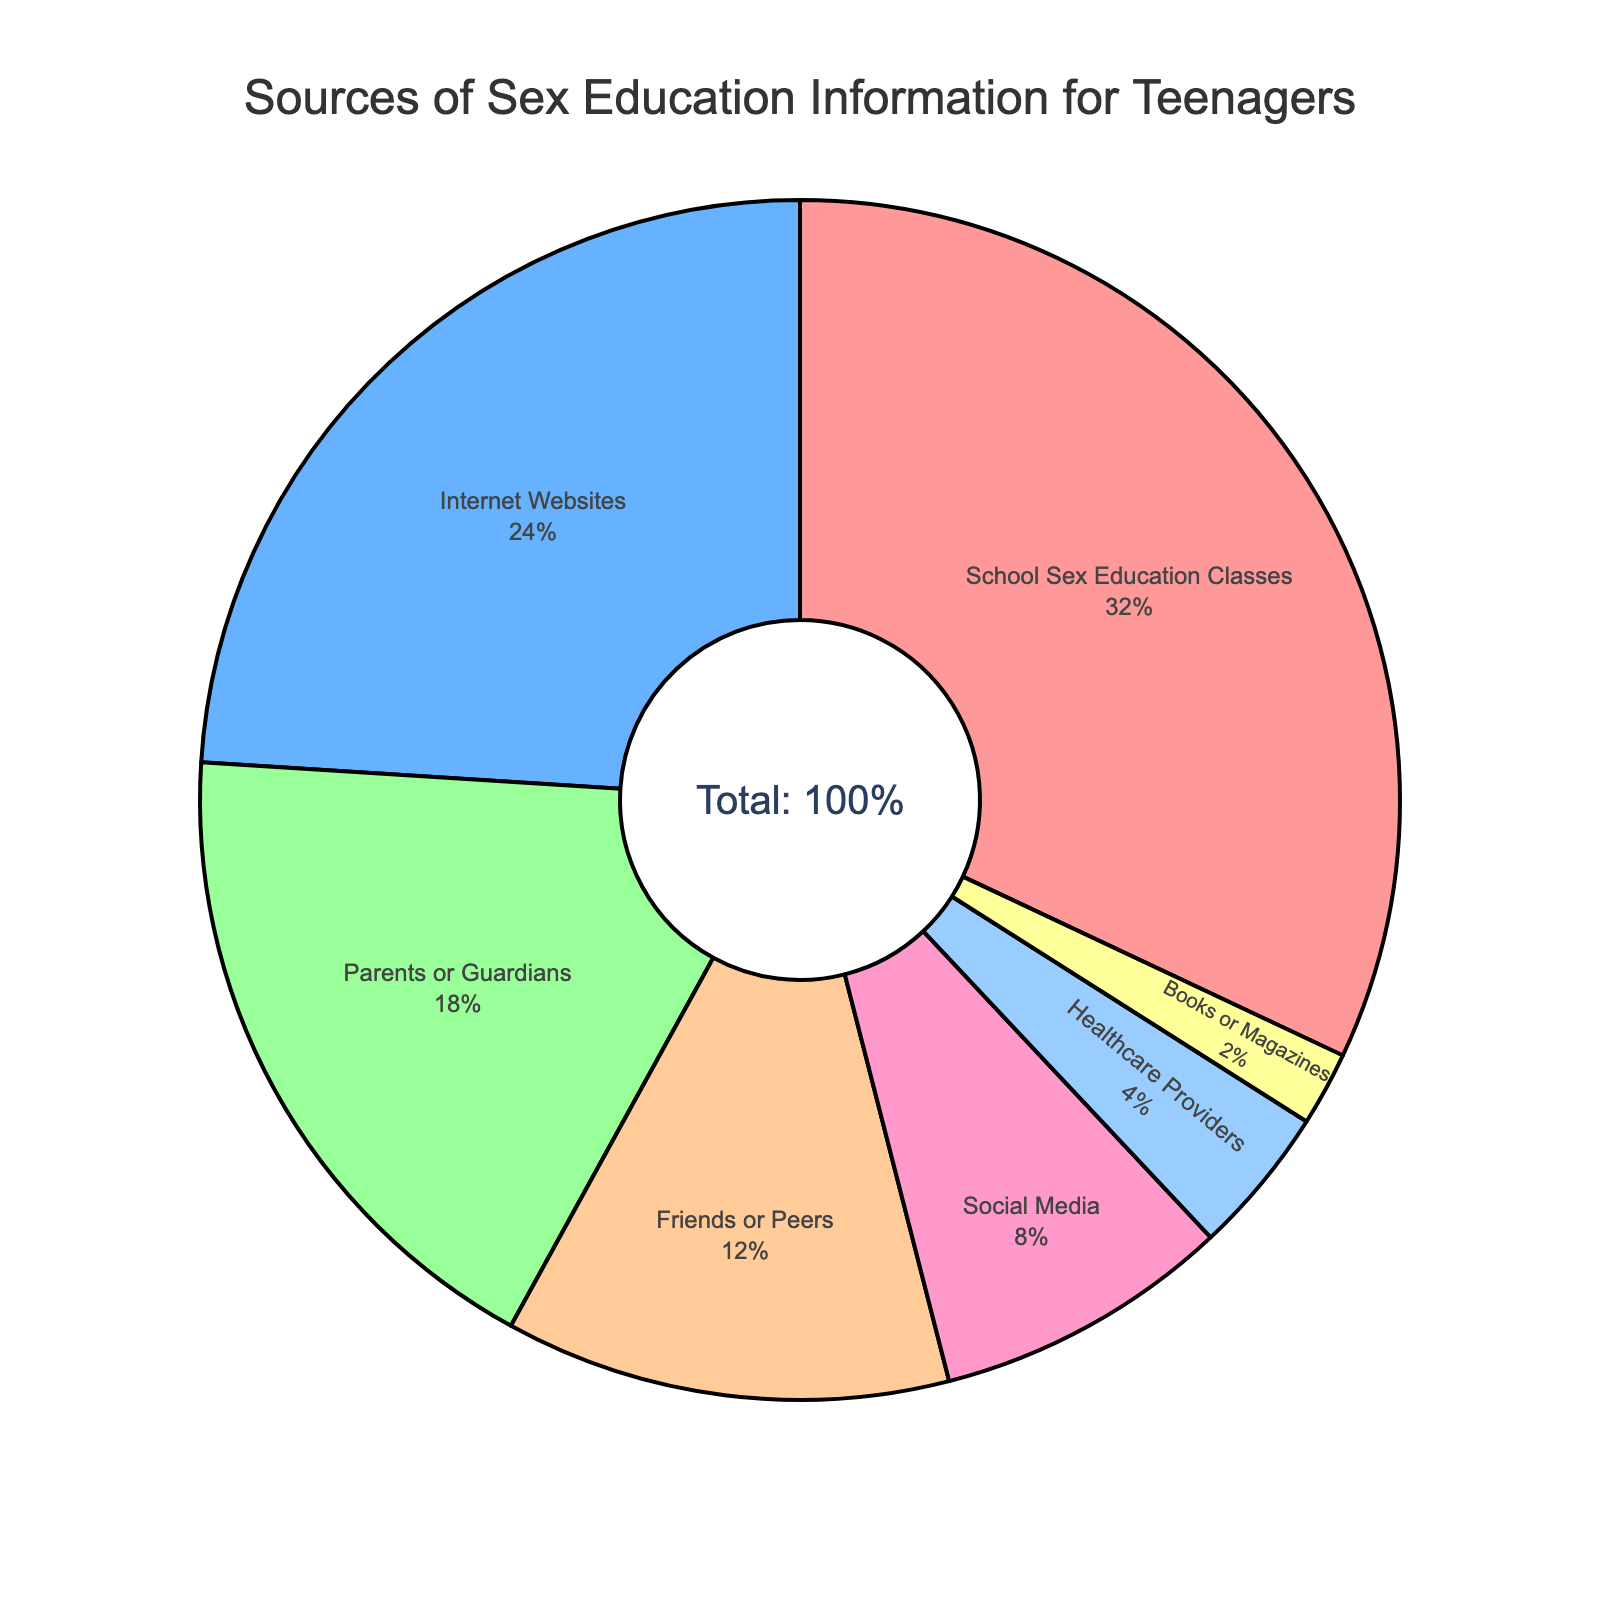What is the most commonly accessed source of sex education information by teenagers? The figure shows the categories and their corresponding percentages. The category with the highest percentage is the most commonly accessed source. According to the pie chart, "School Sex Education Classes" has the largest segment.
Answer: School Sex Education Classes Which source of sex education information is used less than the Internet Websites but more than Healthcare Providers? By looking at the percentages labeled on the pie chart, we can see that "Internet Websites" are at 24%. The next source lower than that is "Parents or Guardians" at 18%, which is also higher than "Healthcare Providers" at 4%.
Answer: Parents or Guardians How much more popular are School Sex Education Classes compared to information from Friends or Peers? First find the percentage for each category: "School Sex Education Classes" is at 32% and "Friends or Peers" is at 12%. Subtract the lower percentage from the higher percentage: 32% - 12% = 20%.
Answer: 20% What is the combined percentage of teenagers who access sex education information from their Parents or Guardians and Friends or Peers? Sum the percentages from both categories: "Parents or Guardians" at 18% and "Friends or Peers" at 12%. The total is 18% + 12% = 30%.
Answer: 30% Which source of sex education information has the smallest segment in the pie chart? Find the category with the lowest percentage. The pie chart shows that "Books or Magazines" have the smallest segment at 2%.
Answer: Books or Magazines Is the percentage of teenagers accessing sex education via Social Media higher or lower than those accessing it through Healthcare Providers, and by how much? Compare the two percentages: "Social Media" is 8% and "Healthcare Providers" is 4%. Subtract the smaller percentage from the larger: 8% - 4% = 4%. "Social Media" is higher.
Answer: Higher by 4% What percentage of teenagers access sex education information from either the Internet Websites or Social Media? Add the percentages of both categories: "Internet Websites" at 24% and "Social Media" at 8%. The sum is 24% + 8% = 32%.
Answer: 32% Do more teenagers rely on the Internet Websites or on their Parents or Guardians for sex education information? Compare the percentages: "Internet Websites" is at 24% and "Parents or Guardians" is at 18%. The higher percentage indicates the more relied-on source.
Answer: Internet Websites What is the proportion of teenagers accessing sex education from sources other than School Sex Education Classes? Subtract the percentage of "School Sex Education Classes" from 100% (since they are part of the whole): 100% - 32% = 68%.
Answer: 68% Between the combined percentages of Internet Websites and Healthcare Providers, and the combined percentages of Parents or Guardians and Friends or Peers, which is higher and by how much? First, sum the relevant percentages: "Internet Websites" at 24% + "Healthcare Providers" at 4% = 28%; "Parents or Guardians" at 18% + "Friends or Peers" at 12% = 30%. Then find the difference: 30% - 28% = 2%.
Answer: Parents or Guardians and Friends or Peers by 2% 